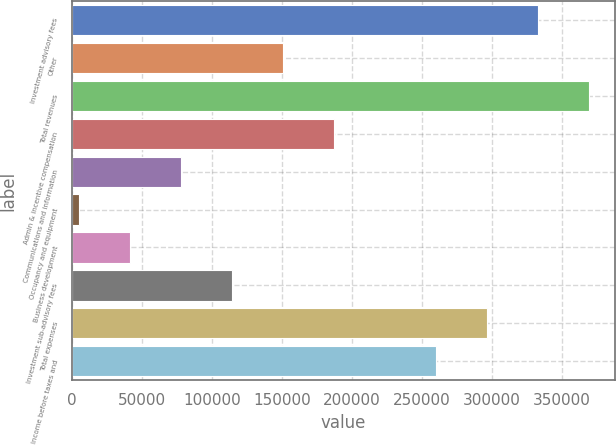Convert chart. <chart><loc_0><loc_0><loc_500><loc_500><bar_chart><fcel>Investment advisory fees<fcel>Other<fcel>Total revenues<fcel>Admin & incentive compensation<fcel>Communications and information<fcel>Occupancy and equipment<fcel>Business development<fcel>Investment sub-advisory fees<fcel>Total expenses<fcel>Income before taxes and<nl><fcel>333180<fcel>150628<fcel>369690<fcel>187138<fcel>77607.6<fcel>4587<fcel>41097.3<fcel>114118<fcel>296669<fcel>260159<nl></chart> 